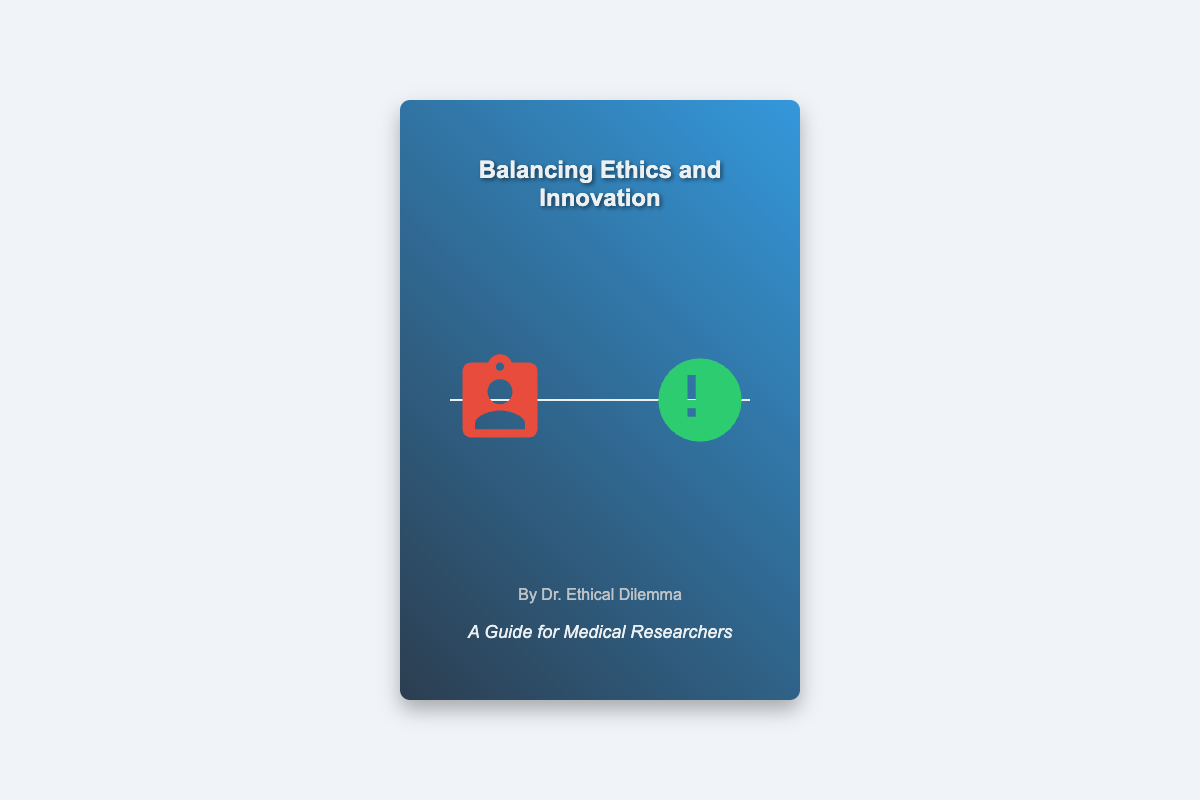What is the title of the book? The title of the book is prominently displayed at the top of the cover.
Answer: Balancing Ethics and Innovation Who is the author of the book? The author’s name is located near the bottom of the cover.
Answer: Dr. Ethical Dilemma What is the subtitle of the book? The subtitle provides a further description of the book's content, found below the title.
Answer: A Guide for Medical Researchers What do the scales symbolize? The scales in the design symbolize the relationship between two important concepts depicted through the images on either side.
Answer: Ethics and Innovation What color is the background of the book cover? The background features a gradient that blends two primary colors.
Answer: Blue and dark blue What is shown on the left side of the scales? The left side of the scales features an element representing a medical aspect.
Answer: Test tubes What is the image on the right side of the scales? The right side of the scales presents an element that signifies human aspects in medical research.
Answer: Human heart What does the book mainly address? The book addresses a critical aspect of conducting research that balances two potentially conflicting priorities.
Answer: Ethical considerations How many words are used in the subtitle? The subtitle consists of a specific number of words detailing the book’s purpose.
Answer: Five words 